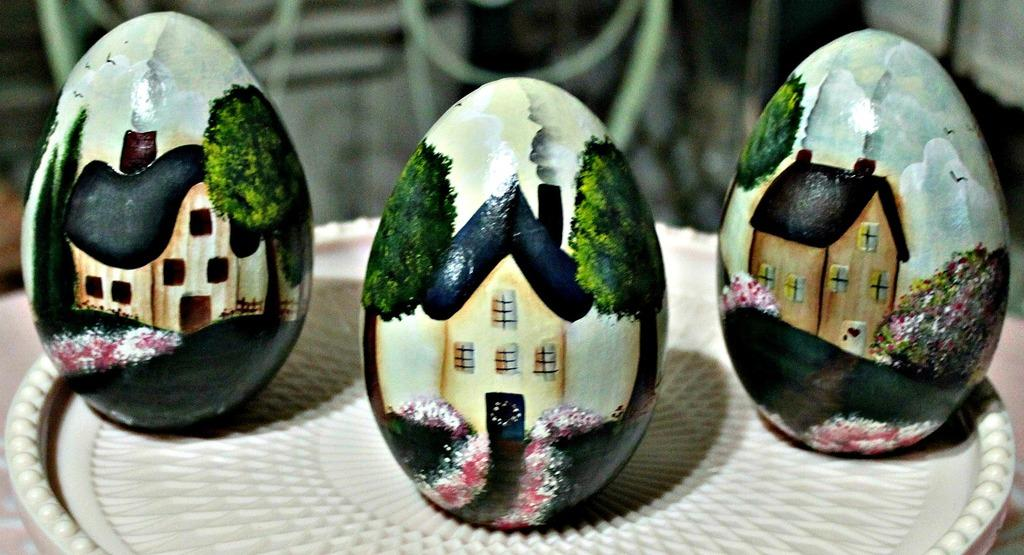How many eggs are visible in the image? There are three eggs in the image. What is depicted on the surface of the eggs? The eggs have a building, trees, and flowers painted on them. Where are the eggs placed in the image? The eggs are on a plate. What is the color of the plate? The plate is white in color. Can you see an icicle hanging from the building painted on the eggs? There is no icicle present in the image; the focus is on the eggs with painted designs. What type of swing is attached to the tree painted on the eggs? There is no swing present in the image; the focus is on the eggs with painted designs. 